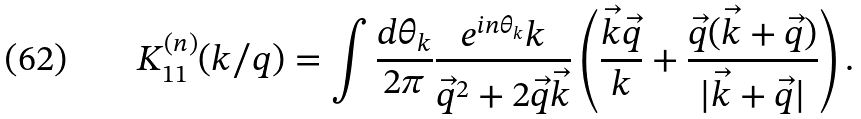<formula> <loc_0><loc_0><loc_500><loc_500>K ^ { ( n ) } _ { 1 1 } ( k / q ) & = \int \frac { d \theta _ { k } } { 2 \pi } \frac { e ^ { i n \theta _ { k } } k } { \vec { q } ^ { 2 } + 2 \vec { q } \vec { k } } \left ( \frac { \vec { k } \vec { q } } { k } + \frac { \vec { q } ( \vec { k } + \vec { q } ) } { | \vec { k } + \vec { q } | } \right ) .</formula> 